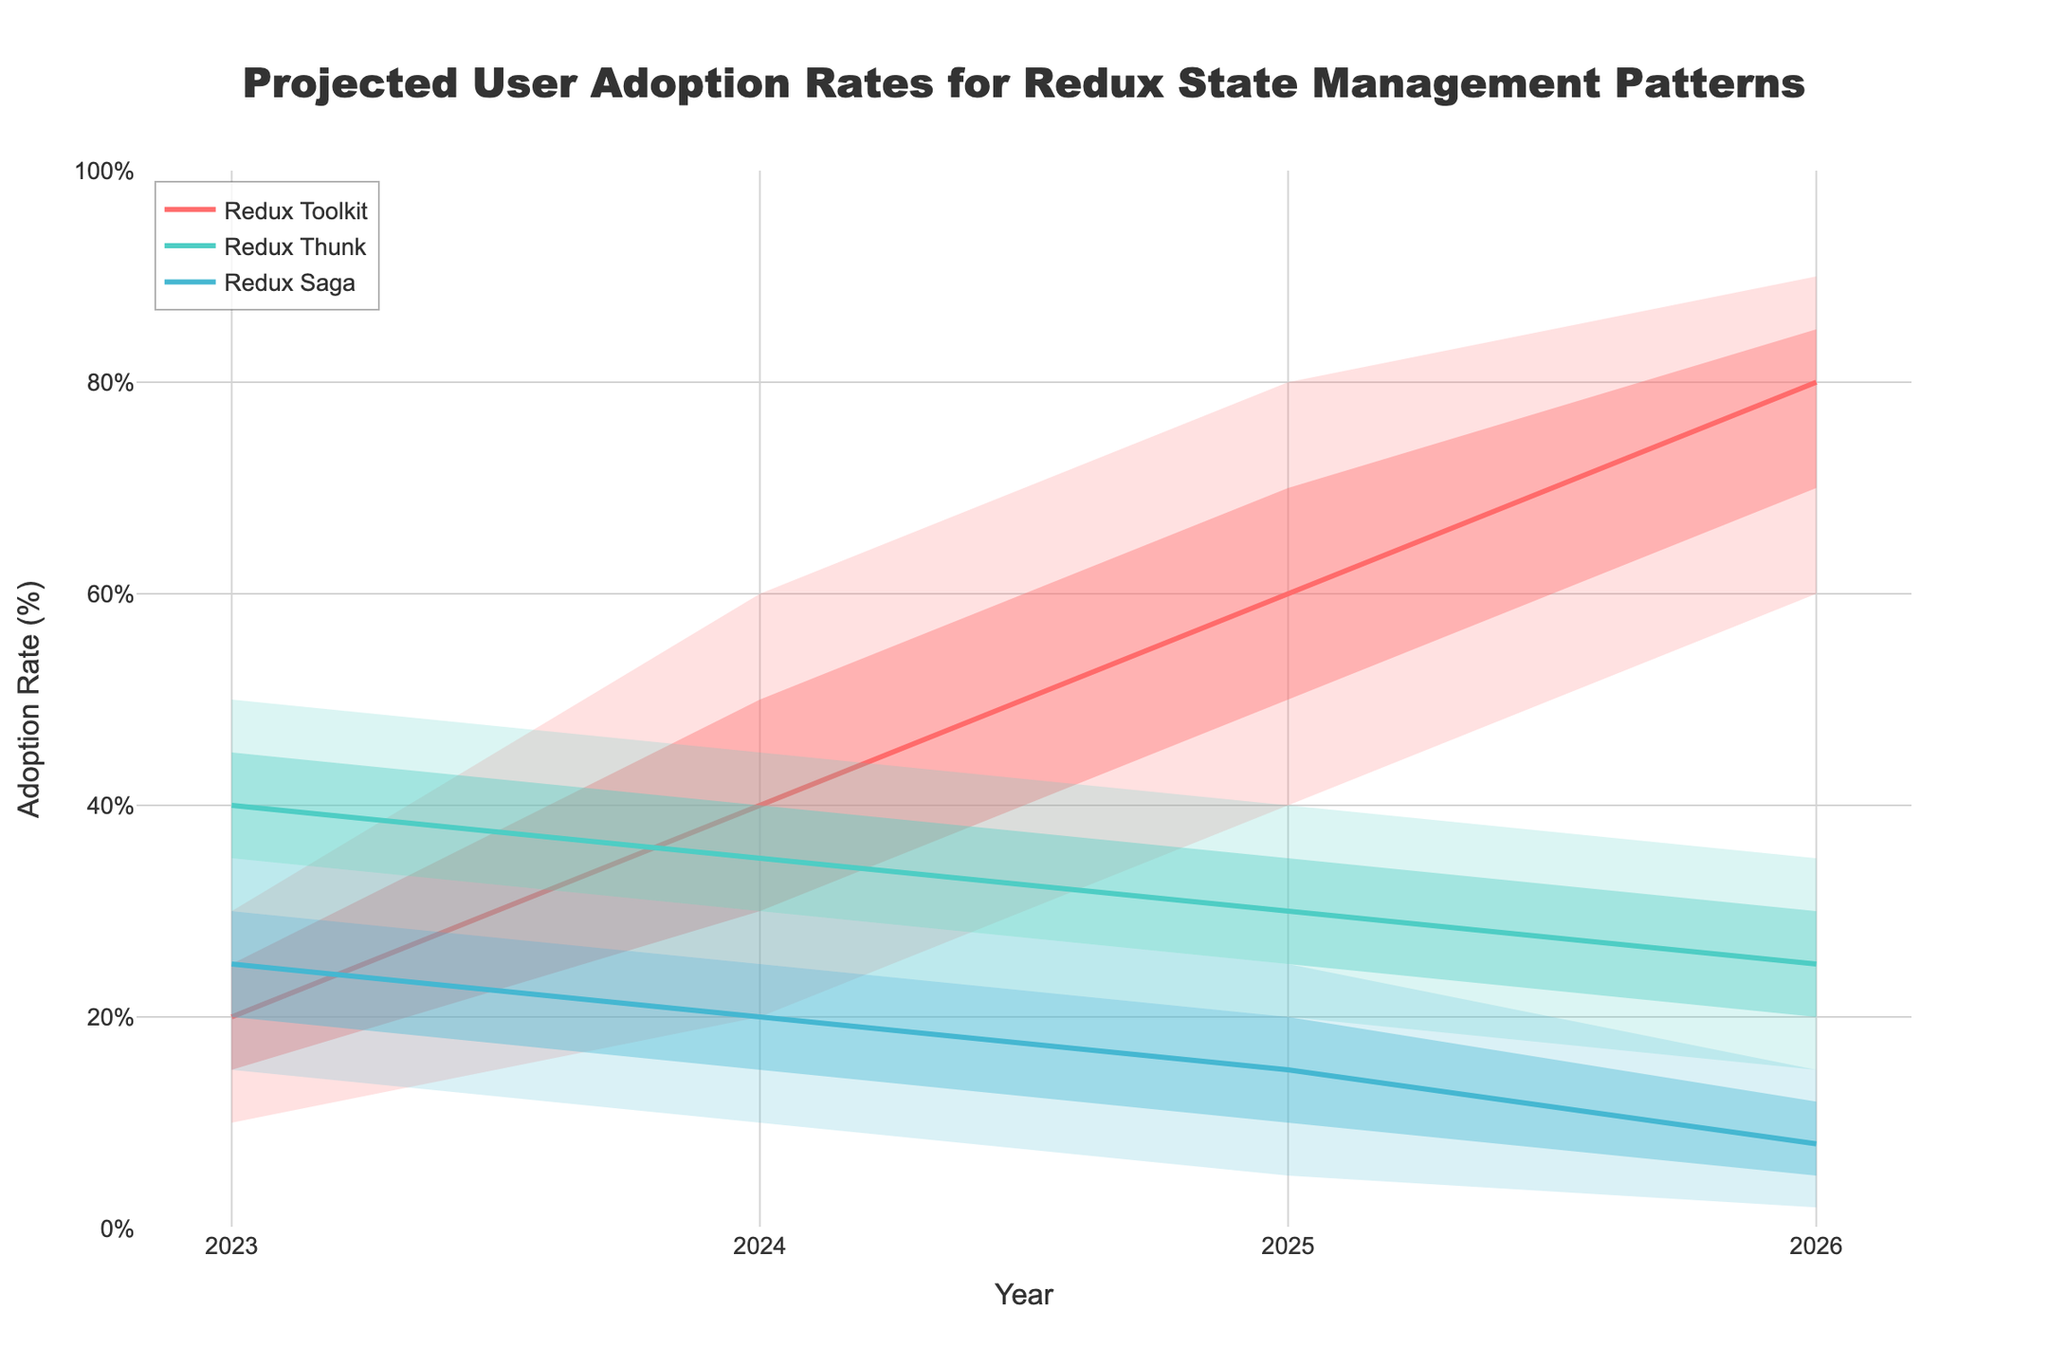What's the title of the figure? The title of the figure is prominently displayed at the top. It reads "Projected User Adoption Rates for Redux State Management Patterns".
Answer: Projected User Adoption Rates for Redux State Management Patterns What is the adoption rate for Redux Toolkit in 2023 according to the median projection? Locate the median line for Redux Toolkit in the year 2023 and note its value on the y-axis. The median projection is represented by a solid line.
Answer: 20% Which Redux pattern shows the highest median adoption rate in 2024? Compare the median adoption rates for all three Redux patterns in 2024 by looking at the solid lines for that year. The pattern with the highest value on the y-axis is the answer.
Answer: Redux Toolkit How does the adoption rate for Redux Saga change from 2023 to 2026 according to the high projection? Examine the high projection lines for Redux Saga from 2023 to 2026, note the values, and understand their trend to infer the change.
Answer: Decreases from 35% to 15% What is the difference between the high and low projections for Redux Thunk in 2025? Identify the high and low projection values for Redux Thunk in 2025 on the y-axis, and then calculate the difference between these values (40 - 20).
Answer: 20% In which year does Redux Toolkit have the widest range between its low and high projections? Calculate the range between the low and high projections for Redux Toolkit in each year by subtracting the low from the high values, then identify the year with the widest range.
Answer: 2026 What is the median projection for Redux Thunk in 2023 and in 2026, and what is the percentage decrease over these years? Identify the median values for Redux Thunk in 2023 and 2026, and calculate the percentage decrease by the formula ((mid2023 - mid2026) / mid2023) * 100.
Answer: 40% to 25%, 37.5% decrease Which Redux pattern is projected to have the lowest adoption rate in 2026 according to the median projection? Compare the median adoption rates in 2026 for all three Redux patterns by looking at the solid lines. The one with the lowest value on the y-axis is the answer.
Answer: Redux Saga How does the range (difference between high and low projections) for Redux Saga change from 2023 to 2026? Calculate the range for Redux Saga in 2023 and 2026 by subtracting the low values from the high values in those years, then compare the two ranges.
Answer: Decreases from 20 to 13 